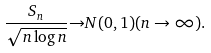<formula> <loc_0><loc_0><loc_500><loc_500>\frac { S _ { n } } { \sqrt { n \log n } } { \to } N ( 0 , 1 ) ( n \to \infty ) .</formula> 